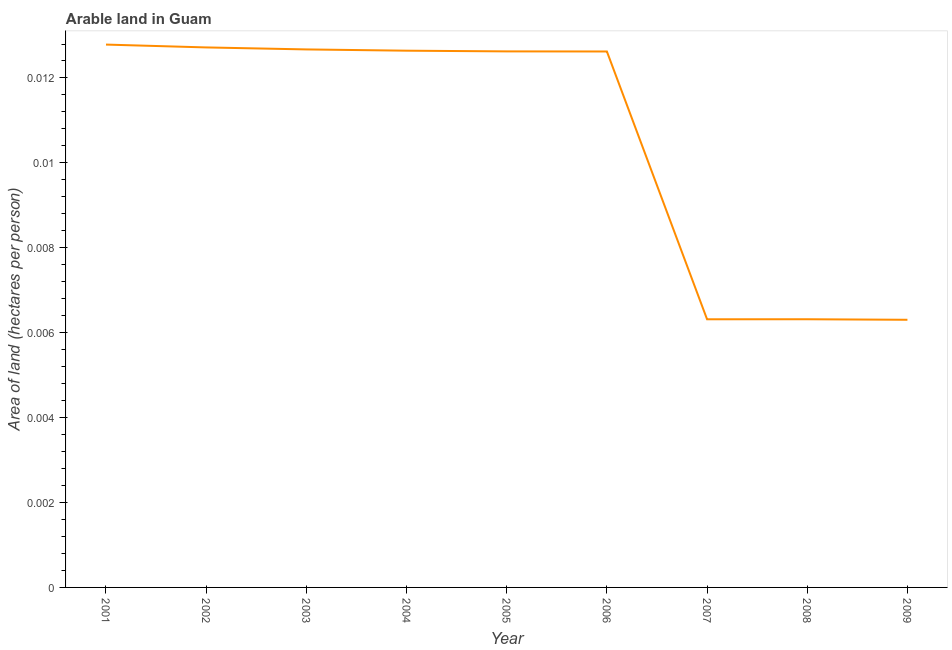What is the area of arable land in 2006?
Give a very brief answer. 0.01. Across all years, what is the maximum area of arable land?
Give a very brief answer. 0.01. Across all years, what is the minimum area of arable land?
Keep it short and to the point. 0.01. What is the sum of the area of arable land?
Keep it short and to the point. 0.1. What is the difference between the area of arable land in 2004 and 2006?
Your answer should be compact. 1.8753104317599523e-5. What is the average area of arable land per year?
Your answer should be very brief. 0.01. What is the median area of arable land?
Provide a short and direct response. 0.01. In how many years, is the area of arable land greater than 0.0044 hectares per person?
Offer a very short reply. 9. What is the ratio of the area of arable land in 2001 to that in 2002?
Offer a very short reply. 1.01. Is the area of arable land in 2005 less than that in 2008?
Your answer should be very brief. No. Is the difference between the area of arable land in 2001 and 2007 greater than the difference between any two years?
Provide a short and direct response. No. What is the difference between the highest and the second highest area of arable land?
Give a very brief answer. 6.700503805119953e-5. What is the difference between the highest and the lowest area of arable land?
Keep it short and to the point. 0.01. Does the area of arable land monotonically increase over the years?
Your answer should be compact. No. How many lines are there?
Offer a very short reply. 1. How many years are there in the graph?
Keep it short and to the point. 9. What is the difference between two consecutive major ticks on the Y-axis?
Keep it short and to the point. 0. Does the graph contain any zero values?
Your response must be concise. No. Does the graph contain grids?
Your response must be concise. No. What is the title of the graph?
Your answer should be very brief. Arable land in Guam. What is the label or title of the Y-axis?
Your answer should be very brief. Area of land (hectares per person). What is the Area of land (hectares per person) in 2001?
Offer a very short reply. 0.01. What is the Area of land (hectares per person) in 2002?
Give a very brief answer. 0.01. What is the Area of land (hectares per person) of 2003?
Provide a succinct answer. 0.01. What is the Area of land (hectares per person) of 2004?
Your answer should be compact. 0.01. What is the Area of land (hectares per person) in 2005?
Provide a short and direct response. 0.01. What is the Area of land (hectares per person) of 2006?
Your answer should be compact. 0.01. What is the Area of land (hectares per person) in 2007?
Provide a short and direct response. 0.01. What is the Area of land (hectares per person) in 2008?
Give a very brief answer. 0.01. What is the Area of land (hectares per person) in 2009?
Your response must be concise. 0.01. What is the difference between the Area of land (hectares per person) in 2001 and 2002?
Keep it short and to the point. 7e-5. What is the difference between the Area of land (hectares per person) in 2001 and 2003?
Your response must be concise. 0. What is the difference between the Area of land (hectares per person) in 2001 and 2004?
Offer a terse response. 0. What is the difference between the Area of land (hectares per person) in 2001 and 2005?
Keep it short and to the point. 0. What is the difference between the Area of land (hectares per person) in 2001 and 2006?
Keep it short and to the point. 0. What is the difference between the Area of land (hectares per person) in 2001 and 2007?
Offer a very short reply. 0.01. What is the difference between the Area of land (hectares per person) in 2001 and 2008?
Ensure brevity in your answer.  0.01. What is the difference between the Area of land (hectares per person) in 2001 and 2009?
Your answer should be compact. 0.01. What is the difference between the Area of land (hectares per person) in 2002 and 2003?
Your answer should be compact. 5e-5. What is the difference between the Area of land (hectares per person) in 2002 and 2004?
Ensure brevity in your answer.  8e-5. What is the difference between the Area of land (hectares per person) in 2002 and 2005?
Ensure brevity in your answer.  9e-5. What is the difference between the Area of land (hectares per person) in 2002 and 2006?
Your answer should be compact. 0. What is the difference between the Area of land (hectares per person) in 2002 and 2007?
Offer a very short reply. 0.01. What is the difference between the Area of land (hectares per person) in 2002 and 2008?
Offer a terse response. 0.01. What is the difference between the Area of land (hectares per person) in 2002 and 2009?
Your answer should be very brief. 0.01. What is the difference between the Area of land (hectares per person) in 2003 and 2004?
Your response must be concise. 3e-5. What is the difference between the Area of land (hectares per person) in 2003 and 2005?
Offer a very short reply. 5e-5. What is the difference between the Area of land (hectares per person) in 2003 and 2006?
Give a very brief answer. 5e-5. What is the difference between the Area of land (hectares per person) in 2003 and 2007?
Keep it short and to the point. 0.01. What is the difference between the Area of land (hectares per person) in 2003 and 2008?
Your answer should be compact. 0.01. What is the difference between the Area of land (hectares per person) in 2003 and 2009?
Your response must be concise. 0.01. What is the difference between the Area of land (hectares per person) in 2004 and 2005?
Provide a succinct answer. 2e-5. What is the difference between the Area of land (hectares per person) in 2004 and 2006?
Provide a short and direct response. 2e-5. What is the difference between the Area of land (hectares per person) in 2004 and 2007?
Keep it short and to the point. 0.01. What is the difference between the Area of land (hectares per person) in 2004 and 2008?
Give a very brief answer. 0.01. What is the difference between the Area of land (hectares per person) in 2004 and 2009?
Ensure brevity in your answer.  0.01. What is the difference between the Area of land (hectares per person) in 2005 and 2007?
Your answer should be compact. 0.01. What is the difference between the Area of land (hectares per person) in 2005 and 2008?
Your answer should be compact. 0.01. What is the difference between the Area of land (hectares per person) in 2005 and 2009?
Make the answer very short. 0.01. What is the difference between the Area of land (hectares per person) in 2006 and 2007?
Provide a succinct answer. 0.01. What is the difference between the Area of land (hectares per person) in 2006 and 2008?
Offer a very short reply. 0.01. What is the difference between the Area of land (hectares per person) in 2006 and 2009?
Your answer should be compact. 0.01. What is the difference between the Area of land (hectares per person) in 2007 and 2008?
Make the answer very short. -0. What is the difference between the Area of land (hectares per person) in 2007 and 2009?
Your response must be concise. 1e-5. What is the difference between the Area of land (hectares per person) in 2008 and 2009?
Make the answer very short. 1e-5. What is the ratio of the Area of land (hectares per person) in 2001 to that in 2002?
Make the answer very short. 1. What is the ratio of the Area of land (hectares per person) in 2001 to that in 2003?
Provide a short and direct response. 1.01. What is the ratio of the Area of land (hectares per person) in 2001 to that in 2005?
Offer a very short reply. 1.01. What is the ratio of the Area of land (hectares per person) in 2001 to that in 2007?
Your response must be concise. 2.02. What is the ratio of the Area of land (hectares per person) in 2001 to that in 2008?
Offer a very short reply. 2.02. What is the ratio of the Area of land (hectares per person) in 2001 to that in 2009?
Your answer should be compact. 2.03. What is the ratio of the Area of land (hectares per person) in 2002 to that in 2004?
Give a very brief answer. 1.01. What is the ratio of the Area of land (hectares per person) in 2002 to that in 2006?
Your response must be concise. 1.01. What is the ratio of the Area of land (hectares per person) in 2002 to that in 2007?
Offer a very short reply. 2.01. What is the ratio of the Area of land (hectares per person) in 2002 to that in 2008?
Your response must be concise. 2.01. What is the ratio of the Area of land (hectares per person) in 2002 to that in 2009?
Make the answer very short. 2.02. What is the ratio of the Area of land (hectares per person) in 2003 to that in 2004?
Your answer should be compact. 1. What is the ratio of the Area of land (hectares per person) in 2003 to that in 2006?
Ensure brevity in your answer.  1. What is the ratio of the Area of land (hectares per person) in 2003 to that in 2007?
Keep it short and to the point. 2.01. What is the ratio of the Area of land (hectares per person) in 2003 to that in 2008?
Provide a succinct answer. 2.01. What is the ratio of the Area of land (hectares per person) in 2003 to that in 2009?
Your answer should be compact. 2.01. What is the ratio of the Area of land (hectares per person) in 2004 to that in 2006?
Make the answer very short. 1. What is the ratio of the Area of land (hectares per person) in 2004 to that in 2007?
Your answer should be compact. 2. What is the ratio of the Area of land (hectares per person) in 2004 to that in 2008?
Your answer should be very brief. 2. What is the ratio of the Area of land (hectares per person) in 2004 to that in 2009?
Offer a very short reply. 2. What is the ratio of the Area of land (hectares per person) in 2005 to that in 2007?
Ensure brevity in your answer.  2. What is the ratio of the Area of land (hectares per person) in 2005 to that in 2008?
Offer a terse response. 2. What is the ratio of the Area of land (hectares per person) in 2005 to that in 2009?
Your answer should be compact. 2. What is the ratio of the Area of land (hectares per person) in 2006 to that in 2007?
Offer a very short reply. 2. What is the ratio of the Area of land (hectares per person) in 2006 to that in 2008?
Provide a succinct answer. 2. What is the ratio of the Area of land (hectares per person) in 2006 to that in 2009?
Give a very brief answer. 2. 